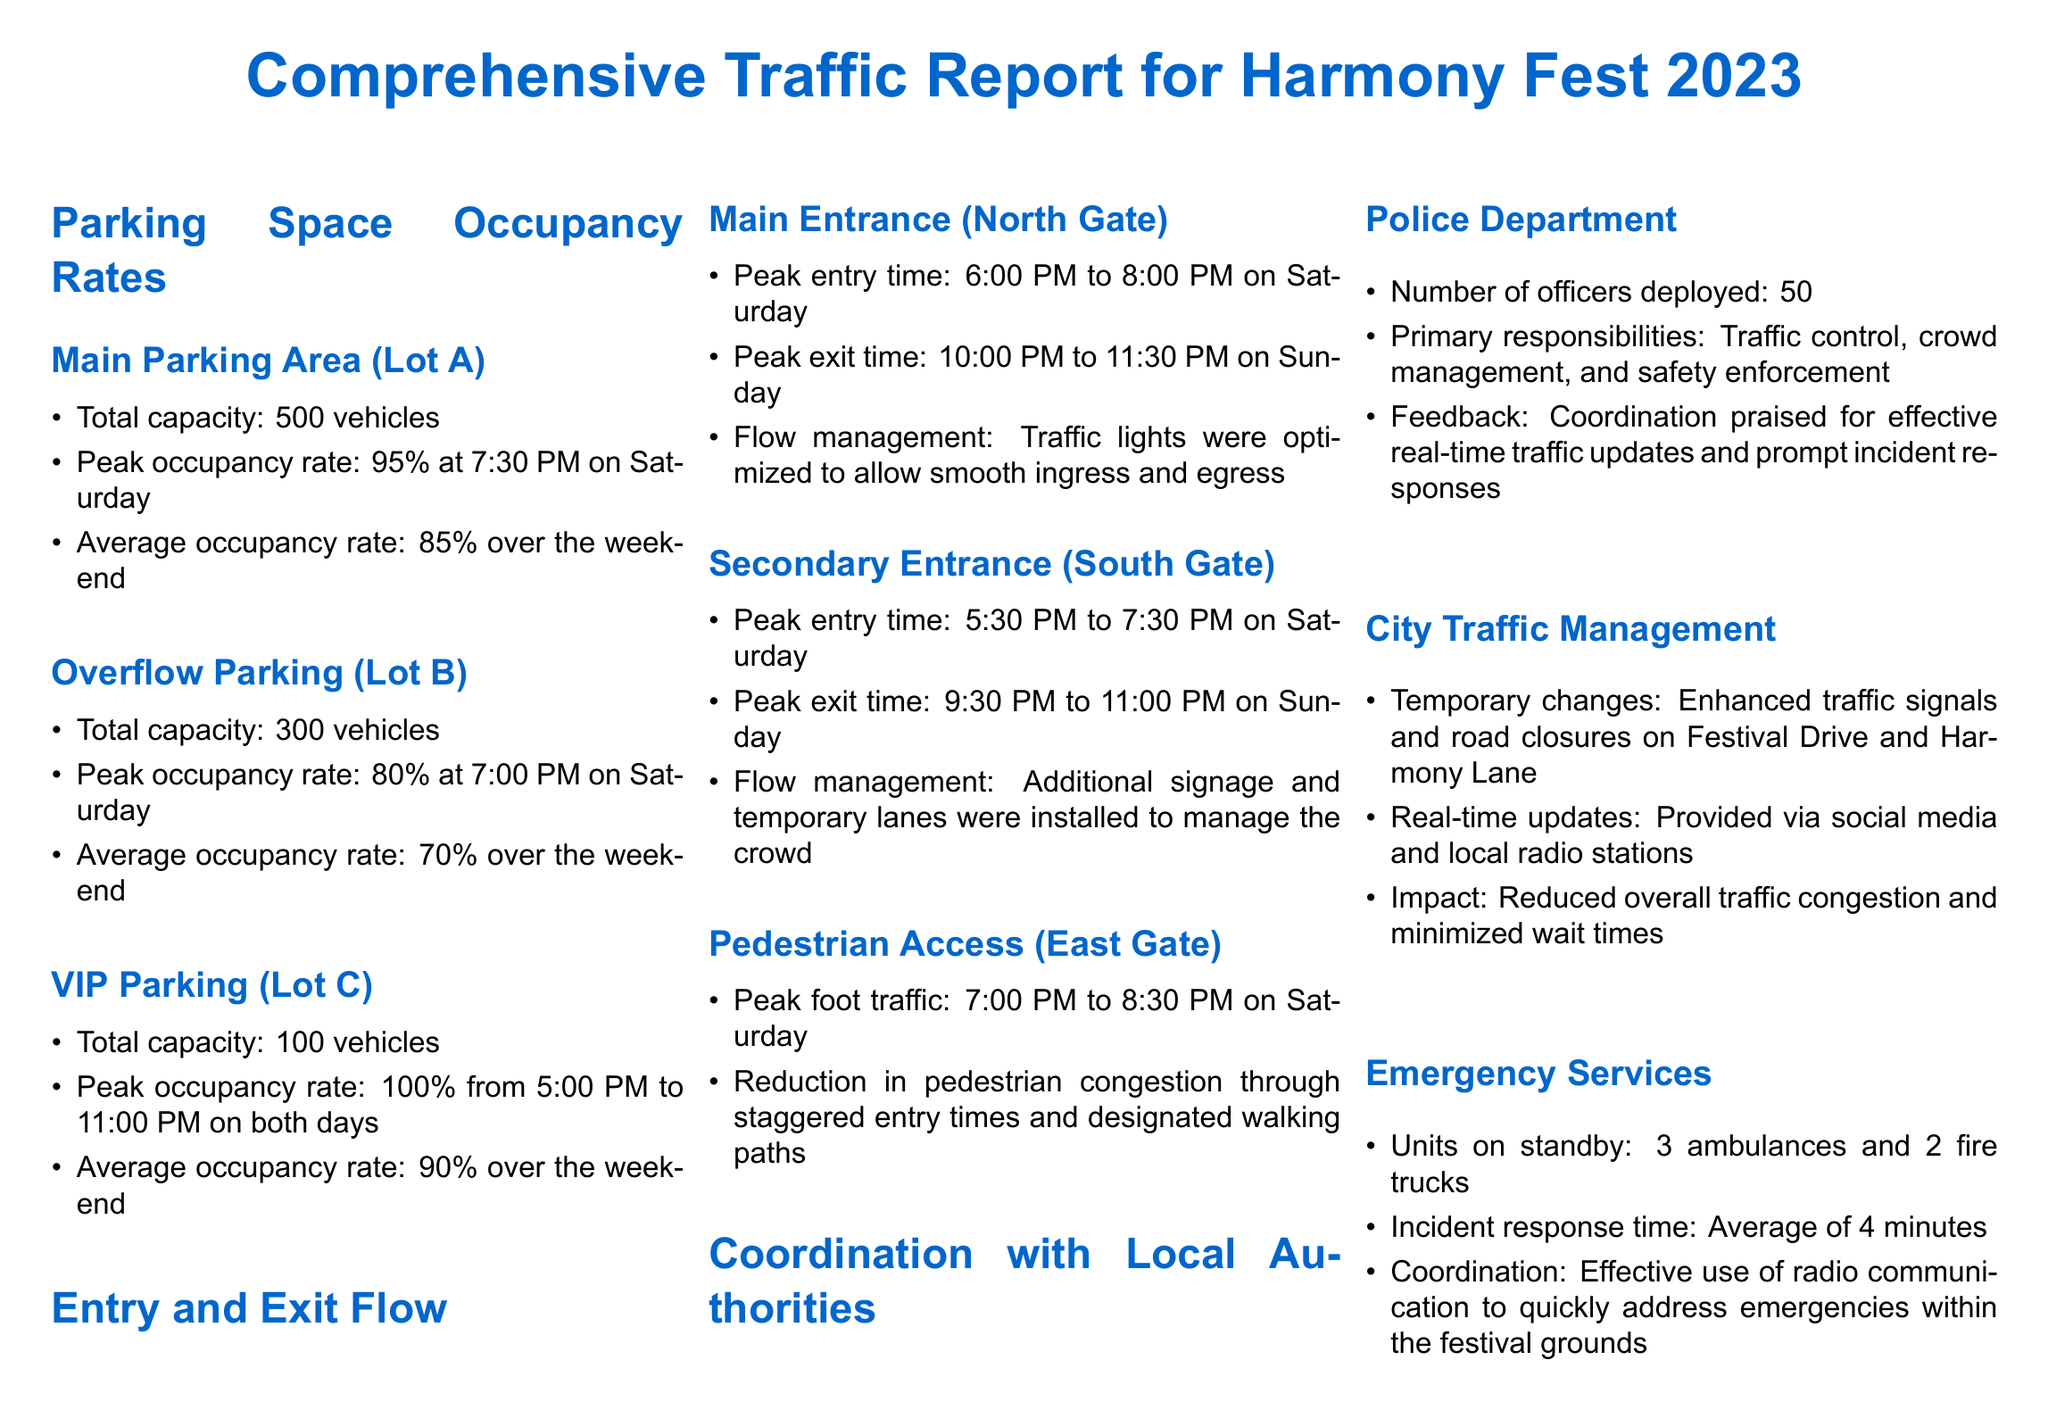What is the total capacity of Main Parking Area (Lot A)? The total capacity for Lot A is explicitly stated in the document.
Answer: 500 vehicles What was the peak occupancy rate for VIP Parking (Lot C)? The peak occupancy rate for Lot C is mentioned in the section regarding VIP parking details.
Answer: 100% What time was the peak entry at the Secondary Entrance (South Gate)? The document specifies the peak entry time at the South Gate.
Answer: 5:30 PM to 7:30 PM How many officers were deployed by the Police Department? The document provides a specific number in the section discussing police coordination.
Answer: 50 What was the average incident response time for Emergency Services? This information is detailed under the Emergency Services coordination section in the document.
Answer: 4 minutes What was the average occupancy rate for the Overflow Parking (Lot B) over the weekend? The average occupancy rate for Lot B is directly provided in the document.
Answer: 70% What kind of updates did City Traffic Management provide? The document describes the type of updates provided by City Traffic Management.
Answer: Real-time updates Which entrance had the peak foot traffic? The document identifies which gate experienced the most foot traffic.
Answer: East Gate What type of coordination was praised by the Police Department? The document states the nature of the feedback received regarding coordination.
Answer: Effective real-time traffic updates 